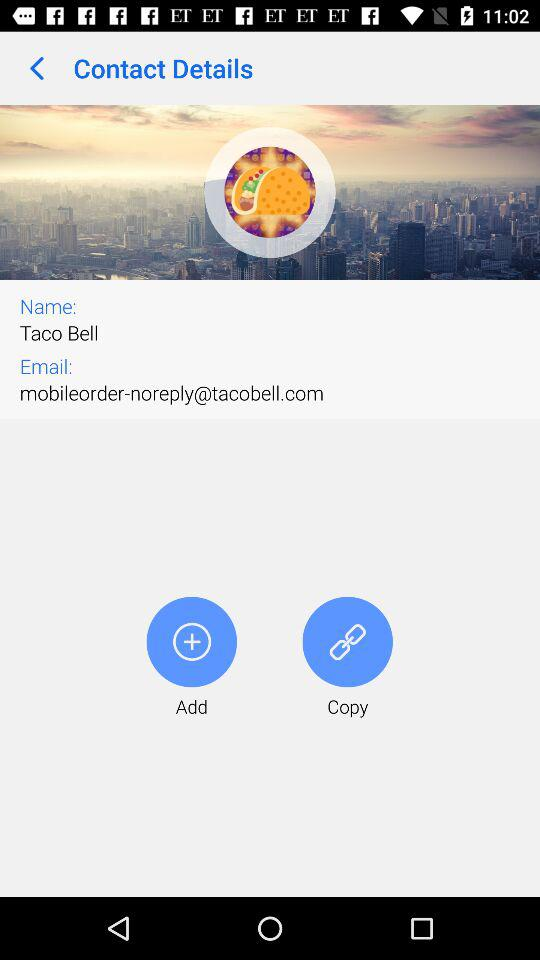What is the email address? The email address is noreply@tacobell.com. 